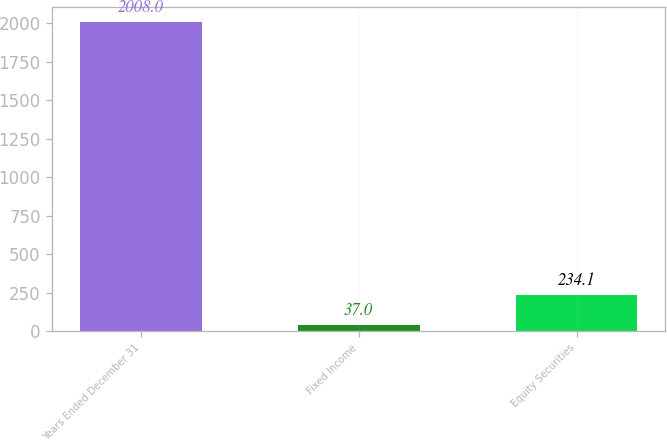Convert chart to OTSL. <chart><loc_0><loc_0><loc_500><loc_500><bar_chart><fcel>Years Ended December 31<fcel>Fixed Income<fcel>Equity Securities<nl><fcel>2008<fcel>37<fcel>234.1<nl></chart> 